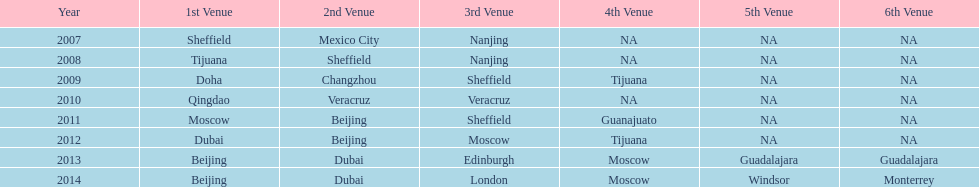Which two places had no countries present from 2007 to 2012? 5th Venue, 6th Venue. 